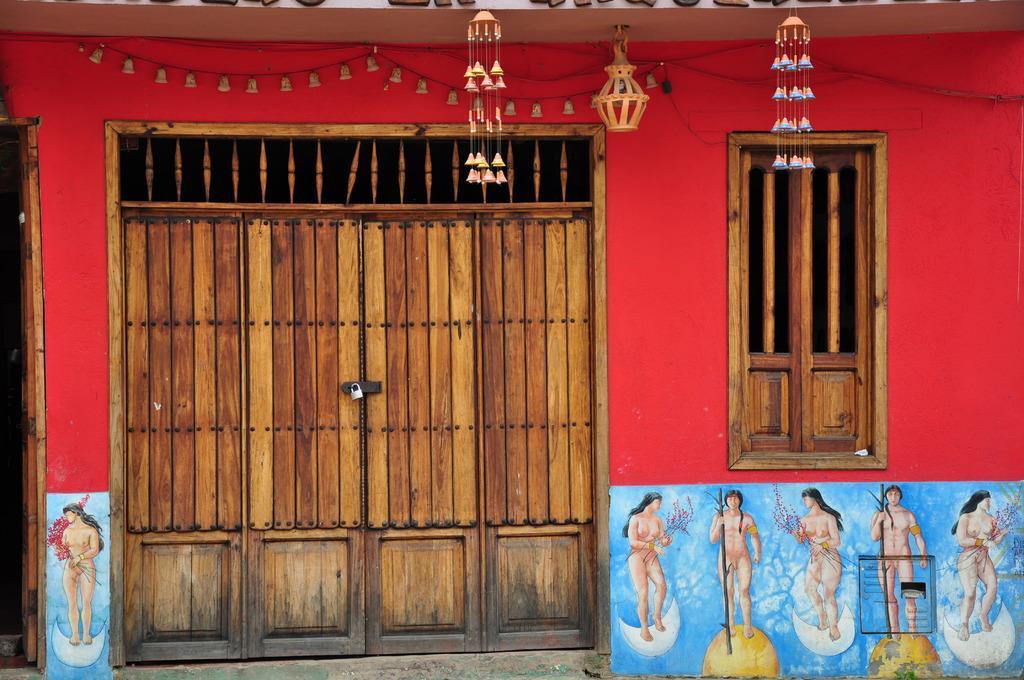Please provide a concise description of this image. In this picture I can see there is a door and it has a lock and it is made of wood and there are pictures of women standing and there are few bells arranged here on the wall. 